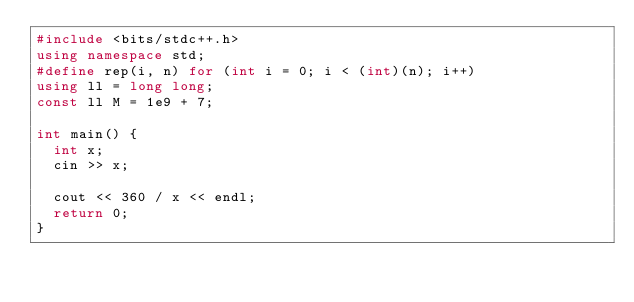Convert code to text. <code><loc_0><loc_0><loc_500><loc_500><_C++_>#include <bits/stdc++.h>
using namespace std;
#define rep(i, n) for (int i = 0; i < (int)(n); i++)
using ll = long long;
const ll M = 1e9 + 7;

int main() {
  int x;
  cin >> x;

  cout << 360 / x << endl;
  return 0;
}</code> 